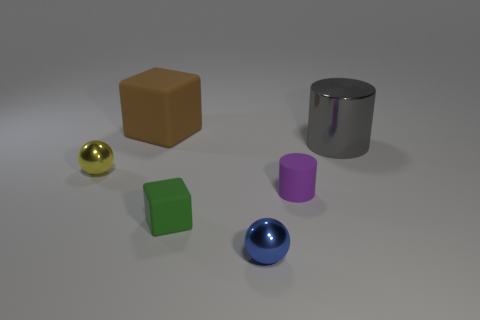Can you tell me the colors of the objects in this image? Certainly! In the image, we see objects of various colors: there is a yellow metal object, a brown rubber block, a silver cylindrical object, and smaller objects in gold, green, blue, and purple hues. 